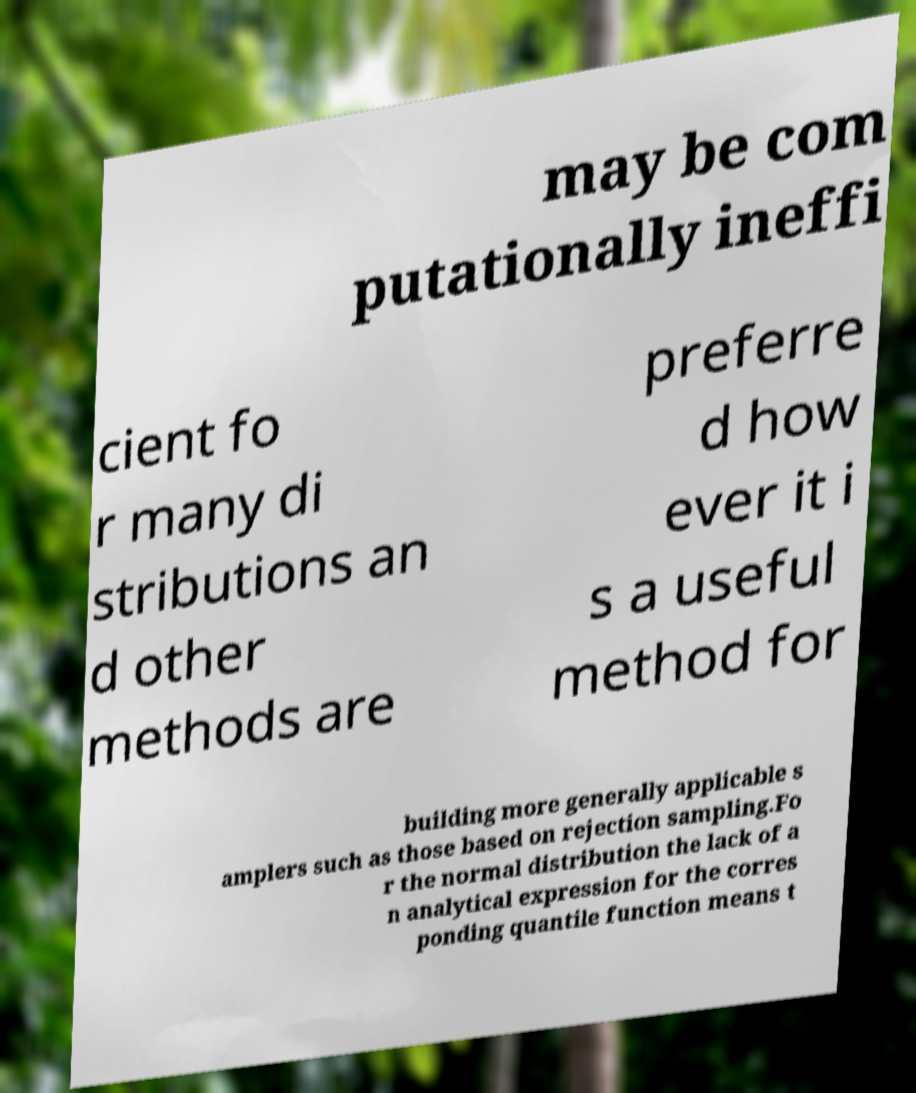What messages or text are displayed in this image? I need them in a readable, typed format. may be com putationally ineffi cient fo r many di stributions an d other methods are preferre d how ever it i s a useful method for building more generally applicable s amplers such as those based on rejection sampling.Fo r the normal distribution the lack of a n analytical expression for the corres ponding quantile function means t 